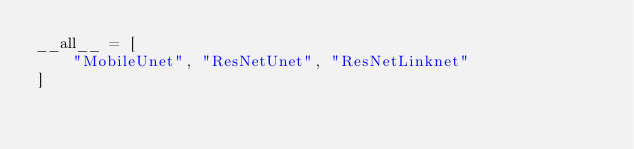Convert code to text. <code><loc_0><loc_0><loc_500><loc_500><_Python_>__all__ = [
    "MobileUnet", "ResNetUnet", "ResNetLinknet"
]
</code> 